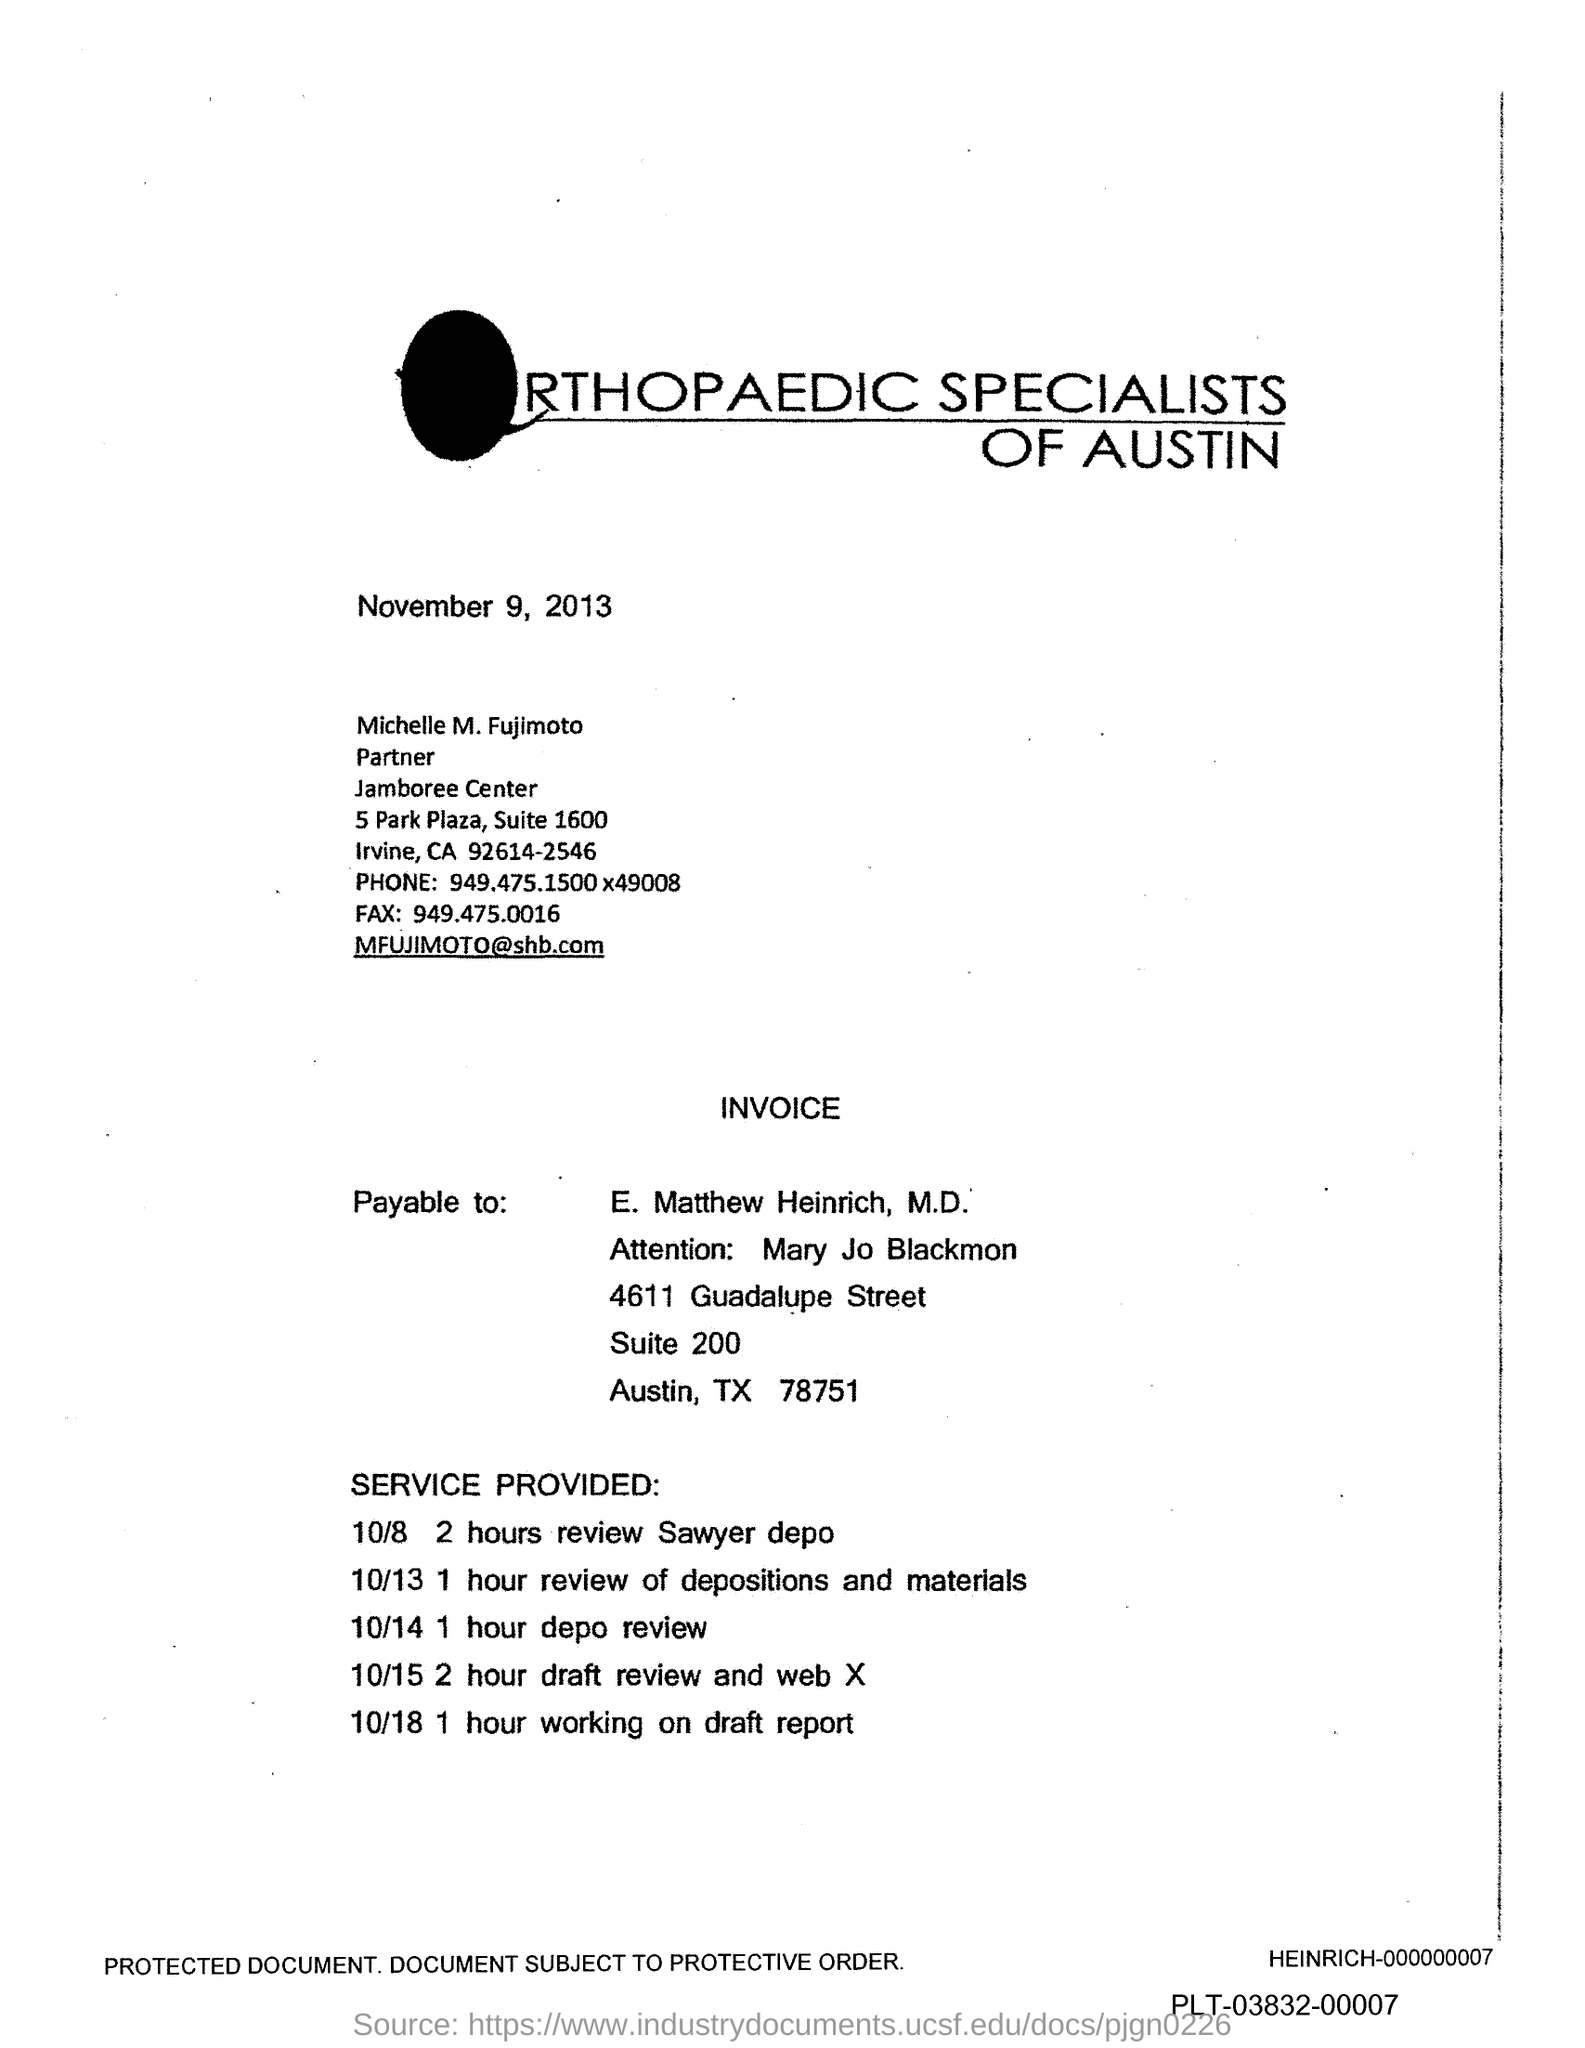Outline some significant characteristics in this image. The document is dated November 9, 2013. The Payable should be made payable to "E. Matthew Heinrich, M.D.". The person being referred to is Mary Jo Blackmon. The 2-hour review Sawyer deposition is scheduled for October 8th. 